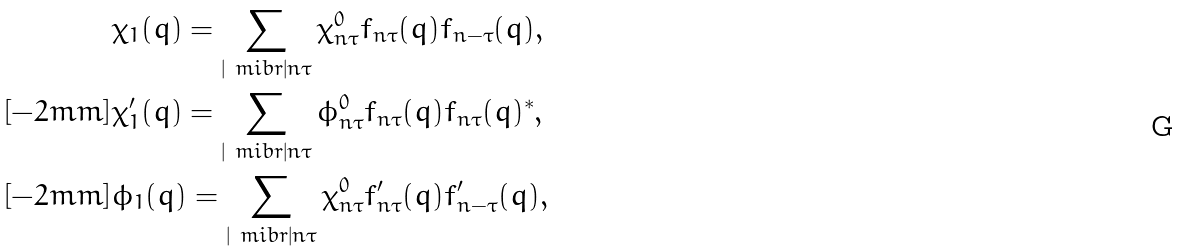<formula> <loc_0><loc_0><loc_500><loc_500>& \chi _ { 1 } ( q ) = \sum _ { | { \ m i b r } | n \tau } \chi ^ { 0 } _ { n \tau } f _ { n \tau } ( q ) f _ { n - \tau } ( q ) , \\ [ - 2 m m ] & \chi ^ { \prime } _ { 1 } ( q ) = \sum _ { | { \ m i b r } | n \tau } \phi ^ { 0 } _ { n \tau } f _ { n \tau } ( q ) f _ { n \tau } ( q ) ^ { * } , \\ [ - 2 m m ] & \phi _ { 1 } ( q ) = \sum _ { | { \ m i b r } | n \tau } \chi ^ { 0 } _ { n \tau } f ^ { \prime } _ { n \tau } ( q ) f ^ { \prime } _ { n - \tau } ( q ) ,</formula> 